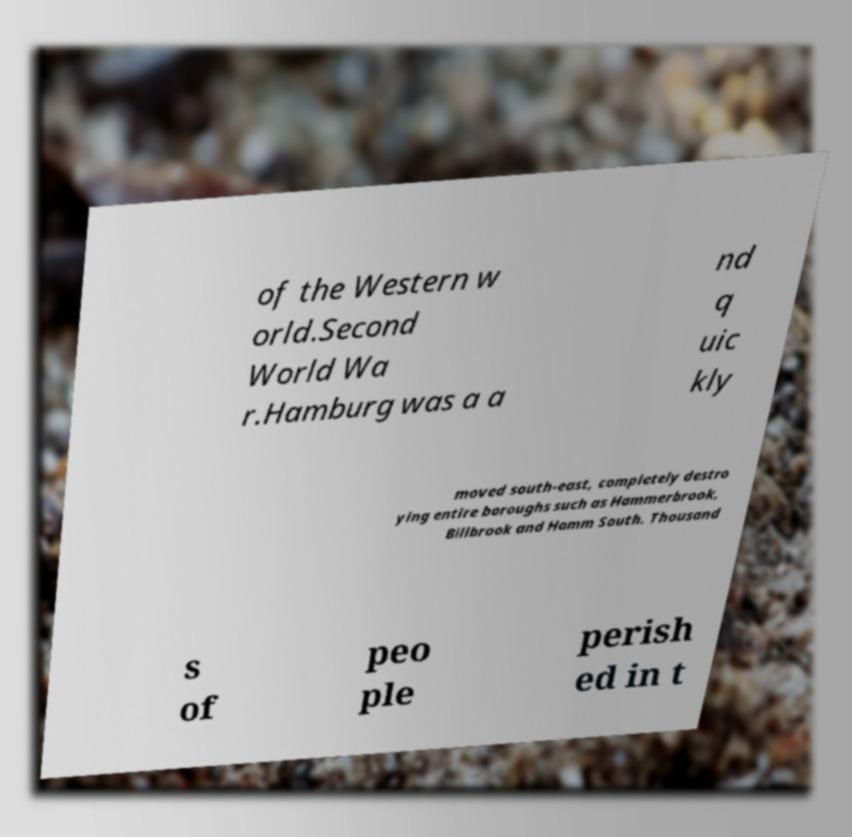Can you read and provide the text displayed in the image?This photo seems to have some interesting text. Can you extract and type it out for me? of the Western w orld.Second World Wa r.Hamburg was a a nd q uic kly moved south-east, completely destro ying entire boroughs such as Hammerbrook, Billbrook and Hamm South. Thousand s of peo ple perish ed in t 